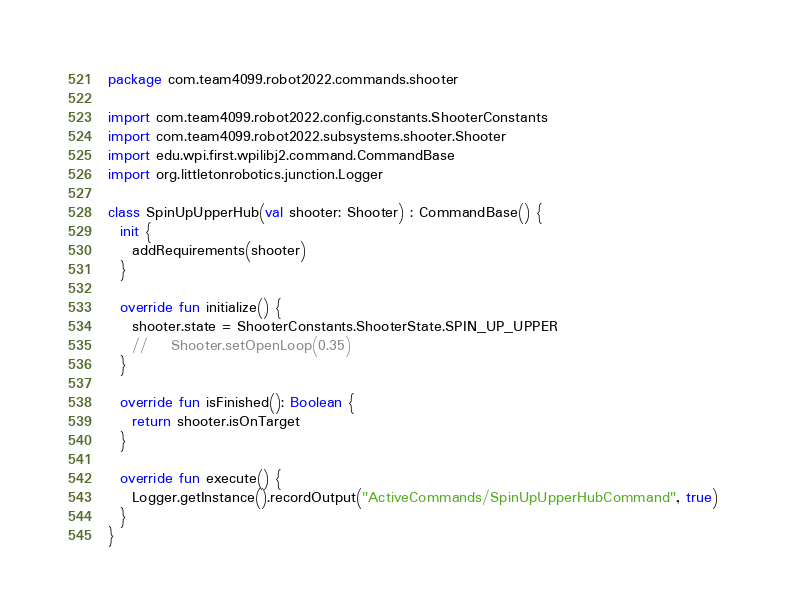<code> <loc_0><loc_0><loc_500><loc_500><_Kotlin_>package com.team4099.robot2022.commands.shooter

import com.team4099.robot2022.config.constants.ShooterConstants
import com.team4099.robot2022.subsystems.shooter.Shooter
import edu.wpi.first.wpilibj2.command.CommandBase
import org.littletonrobotics.junction.Logger

class SpinUpUpperHub(val shooter: Shooter) : CommandBase() {
  init {
    addRequirements(shooter)
  }

  override fun initialize() {
    shooter.state = ShooterConstants.ShooterState.SPIN_UP_UPPER
    //    Shooter.setOpenLoop(0.35)
  }

  override fun isFinished(): Boolean {
    return shooter.isOnTarget
  }

  override fun execute() {
    Logger.getInstance().recordOutput("ActiveCommands/SpinUpUpperHubCommand", true)
  }
}
</code> 